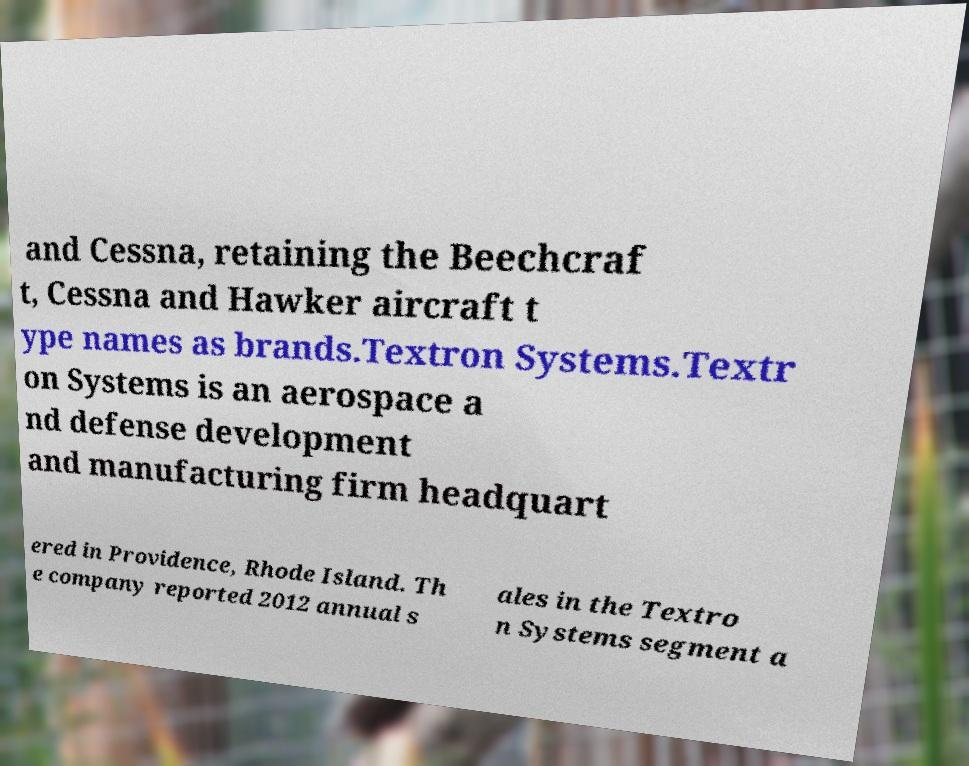Can you accurately transcribe the text from the provided image for me? and Cessna, retaining the Beechcraf t, Cessna and Hawker aircraft t ype names as brands.Textron Systems.Textr on Systems is an aerospace a nd defense development and manufacturing firm headquart ered in Providence, Rhode Island. Th e company reported 2012 annual s ales in the Textro n Systems segment a 